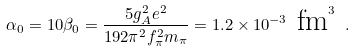Convert formula to latex. <formula><loc_0><loc_0><loc_500><loc_500>\alpha _ { 0 } = 1 0 \beta _ { 0 } = \frac { 5 g _ { A } ^ { 2 } e ^ { 2 } } { 1 9 2 \pi ^ { 2 } f _ { \pi } ^ { 2 } m _ { \pi } } = 1 . 2 \times 1 0 ^ { - 3 } \text { fm} ^ { 3 } \ .</formula> 